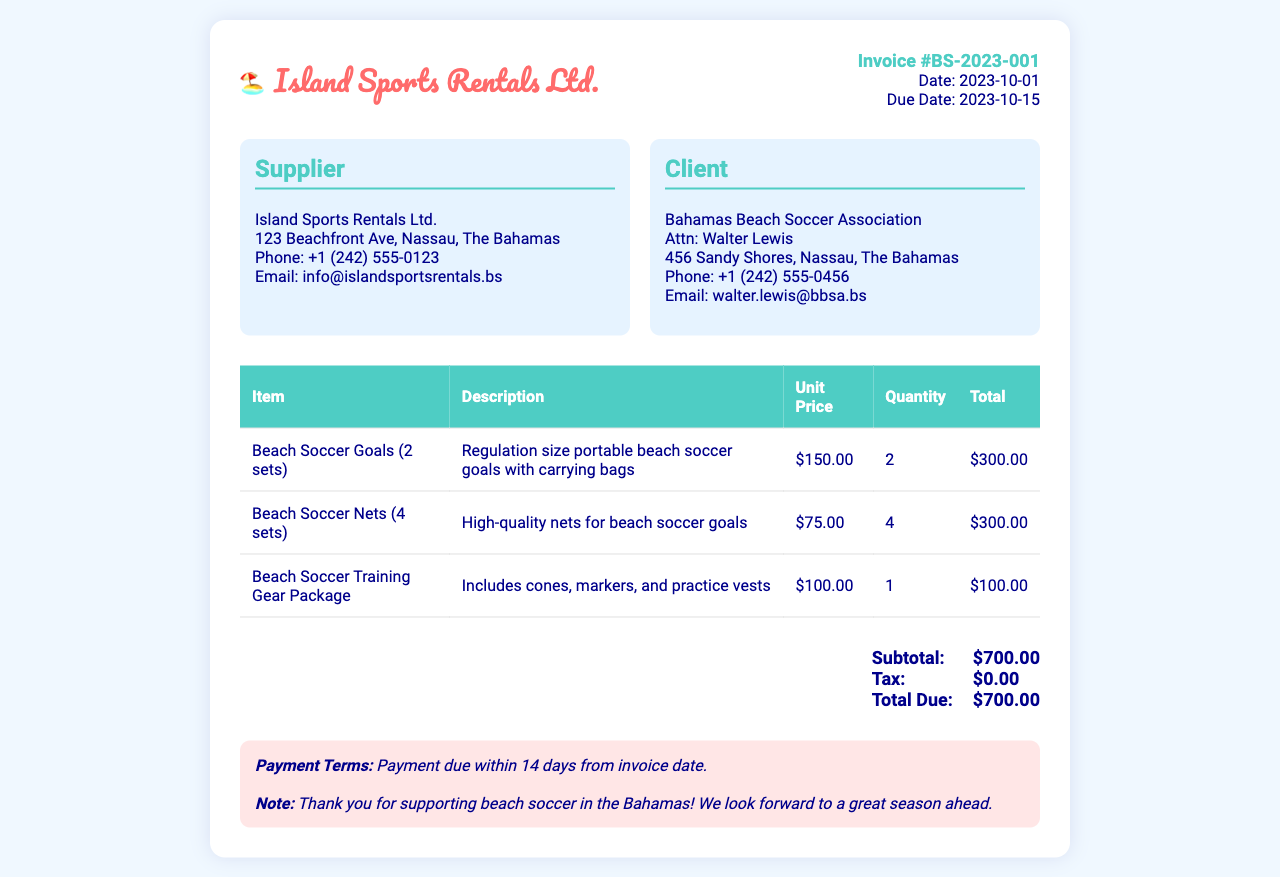What is the invoice number? The invoice number is clearly stated in the document as part of the invoice details.
Answer: BS-2023-001 What is the due date for the invoice? The due date is provided under the invoice details section.
Answer: 2023-10-15 Who is the client? The client is indicated in the client information box.
Answer: Bahamas Beach Soccer Association How many beach soccer goals are rented? The quantity is specified in the itemized list of the rental items.
Answer: 2 What is the subtotal amount? The subtotal is explicitly mentioned in the total section of the invoice.
Answer: $700.00 What item includes cones, markers, and practice vests? The document specifies which items belong to the training gear package.
Answer: Beach Soccer Training Gear Package What is the total due amount? The total due is summarized in the totals section of the invoice.
Answer: $700.00 What is the supplier's phone number? The supplier's contact information includes a phone number.
Answer: +1 (242) 555-0123 What is the payment term? The payment terms are noted at the bottom of the invoice.
Answer: Payment due within 14 days from invoice date 